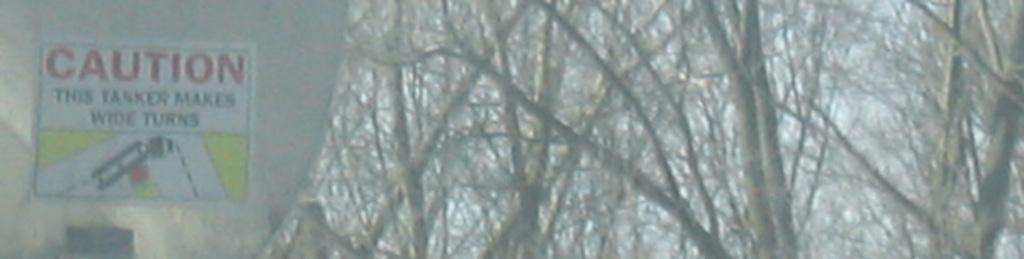In one or two sentences, can you explain what this image depicts? This picture is clicked outside. On the left we can see an object on which we can see the poster and the text on the poster. On the right we can see the sky and the branches and stems of the trees and some other objects. 